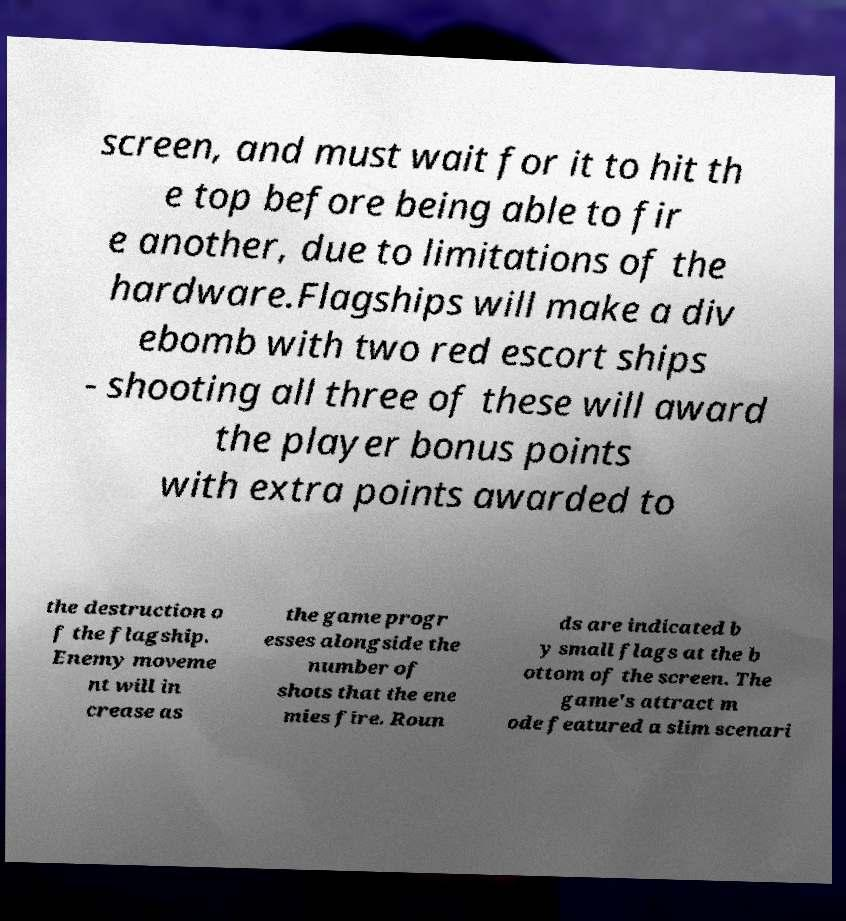Could you assist in decoding the text presented in this image and type it out clearly? screen, and must wait for it to hit th e top before being able to fir e another, due to limitations of the hardware.Flagships will make a div ebomb with two red escort ships - shooting all three of these will award the player bonus points with extra points awarded to the destruction o f the flagship. Enemy moveme nt will in crease as the game progr esses alongside the number of shots that the ene mies fire. Roun ds are indicated b y small flags at the b ottom of the screen. The game's attract m ode featured a slim scenari 